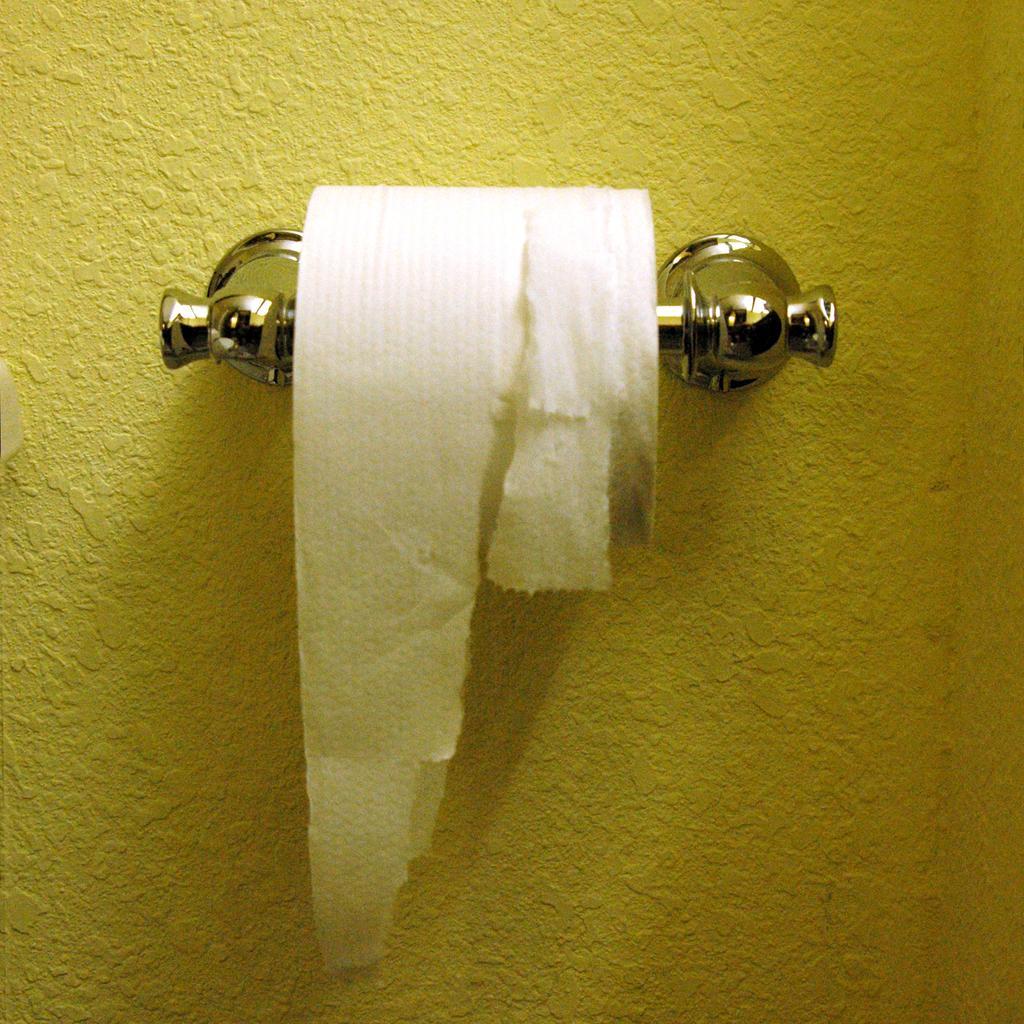Describe this image in one or two sentences. A tissue paper holder along with tissue paper roll is attached to the yellow wall. 